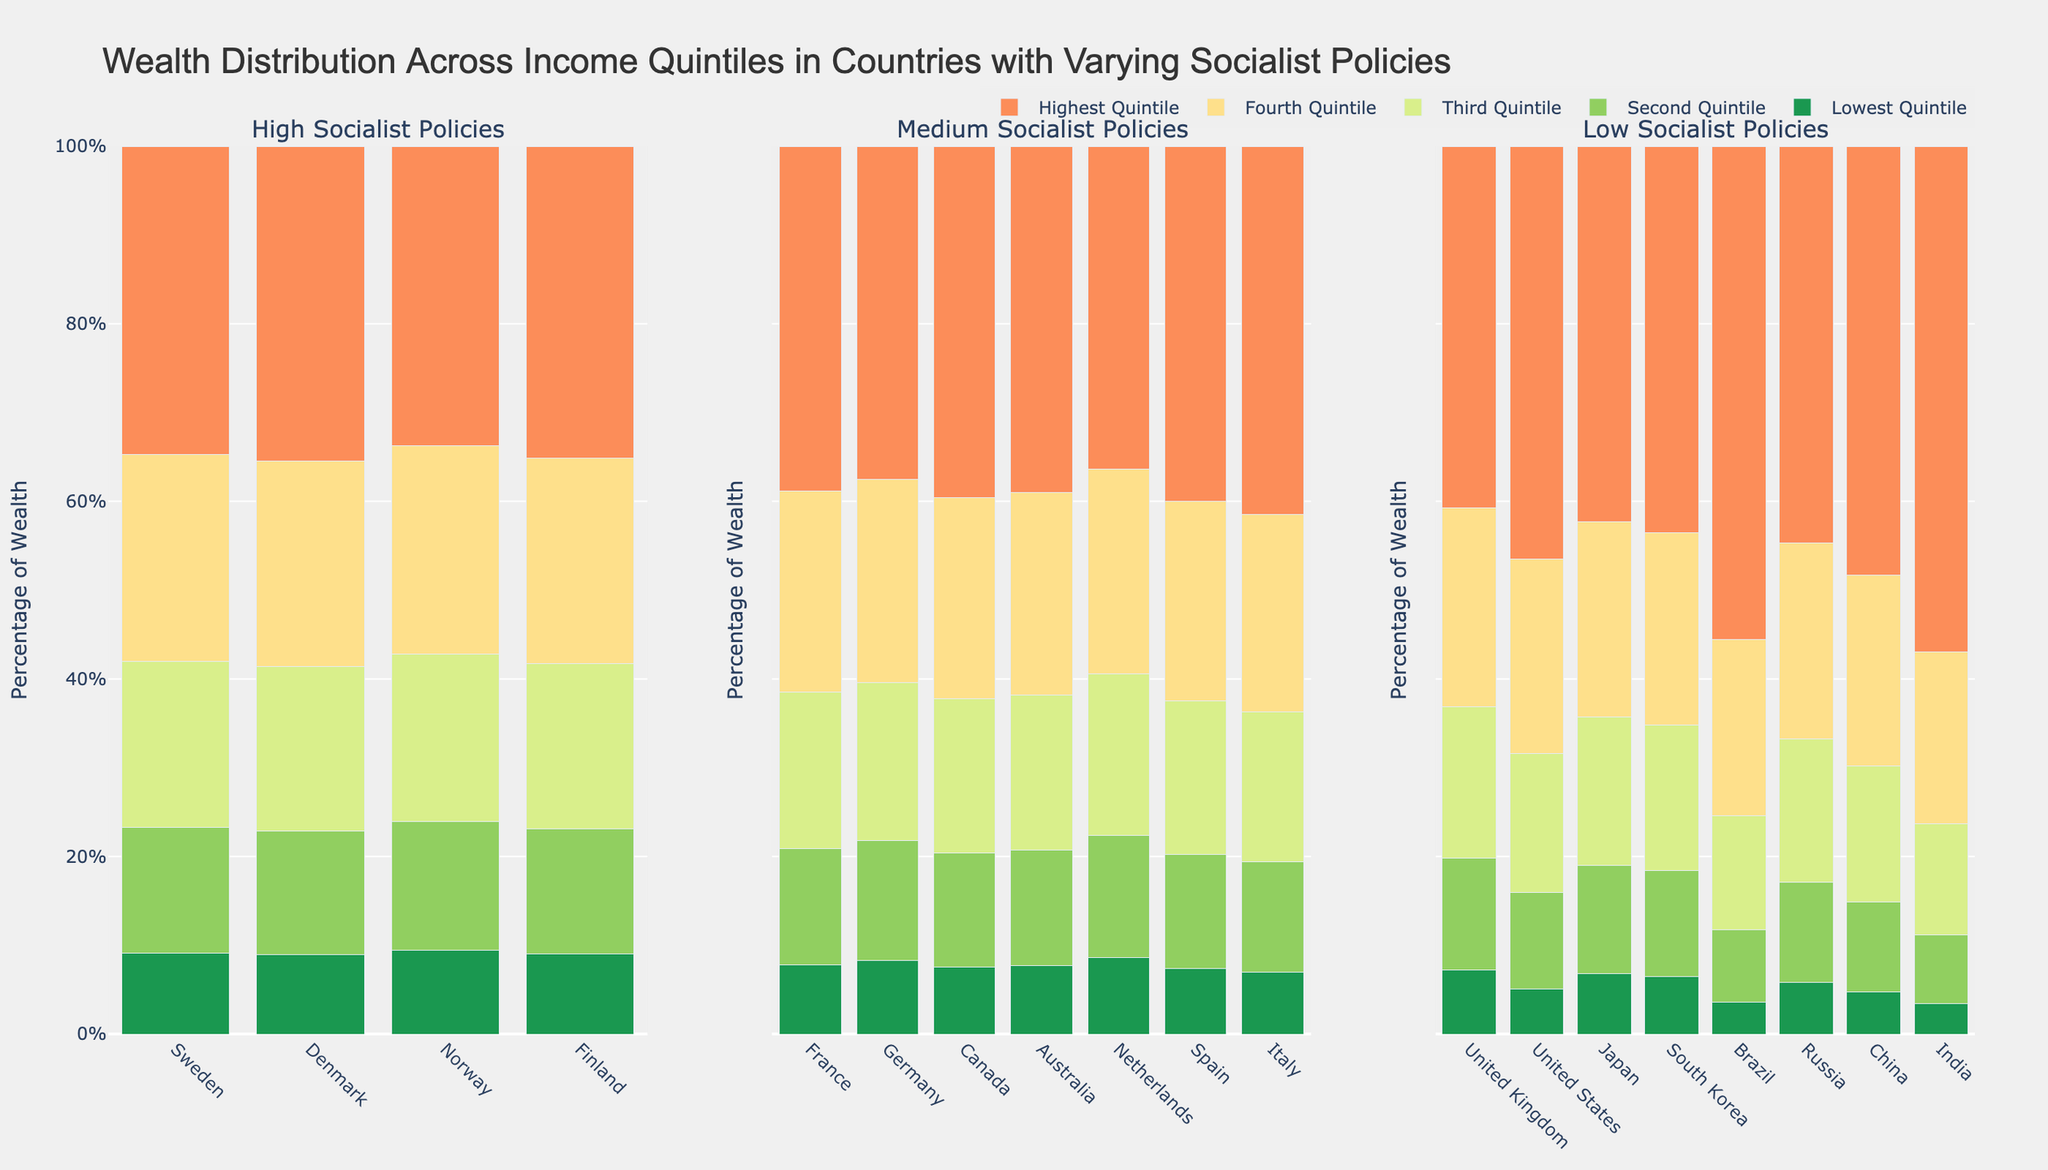What country with high socialist policies has the most equal wealth distribution across quintiles? Observing the three countries with high socialist policies in the figure, it's evident that Norway has the most balanced distribution, where the wealth across quintiles is most evenly spread out (lowest quintile: 9.4, highest quintile: 33.7).
Answer: Norway Which country has the highest wealth percentage in the lowest quintile, and what is that percentage? Looking at the bars representing the lowest quintile, Norway has the highest at 9.4%.
Answer: Norway, 9.4% Among countries with medium socialist policies, which one has the highest wealth percentage in the highest quintile? In the category of medium socialist policies, France has the highest wealth percentage in the highest quintile, which is 38.8%.
Answer: France, 38.8% Compare the wealth percentage in the highest quintile between the USA and Sweden. Which country has a higher percentage, and by how much? The USA has 46.5% in the highest quintile, and Sweden has 34.7%. The difference is 46.5 - 34.7 = 11.8%.
Answer: USA by 11.8% What is the average wealth percentage of the lowest quintile for countries with low socialist policies? Add the wealth percentages for the lowest quintile in low socialist policy countries and divide by the number of these countries: (5.1+7.2+6.8+6.5+3.6+5.8+4.7+3.4)/8 = 5.14%.
Answer: 5.14% Which quintile has the most consistent wealth percentage across countries with high socialist policies? By looking at the widths of the bars for each policy level and quintile, the lowest quintile shows consistency, all around 9%.
Answer: Lowest Quintile Compare the wealth in the third quintile between France and Germany. Which country has a higher percentage and by how much? France has 17.6% and Germany has 17.8% in the third quintile. Germany has a higher percentage by 0.2%.
Answer: Germany by 0.2% Which quintile shows the largest difference in wealth percentage between high and low socialist policies? The highest quintile shows the largest difference. For high socialist policies, the highest quintile's percentages range around 33.7-35.5%, while for low socialist policies, the range is significantly larger, from 40.7-57%.
Answer: Highest Quintile Which country has the smallest percentage in the second quintile and what is that percentage? By observing the second quintile bars, India has the smallest percentage at 7.8%.
Answer: India, 7.8% How much more wealth does the highest quintile in China have compared to the lowest quintile in China? The wealth percentage for the highest quintile in China is 48.3%, and for the lowest quintile, it is 4.7%. So, the difference is 48.3 - 4.7 = 43.6%.
Answer: 43.6% 